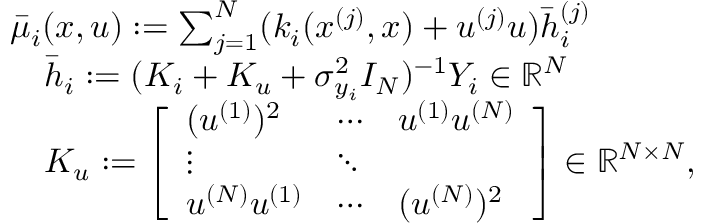<formula> <loc_0><loc_0><loc_500><loc_500>\begin{array} { r l } & { \bar { \mu } _ { i } ( x , u ) \colon = \sum _ { j = 1 } ^ { N } ( k _ { i } ( x ^ { ( j ) } , x ) + u ^ { ( j ) } u ) \bar { h } _ { i } ^ { ( j ) } } \\ & { \quad \bar { h } _ { i } \colon = ( K _ { i } + K _ { u } + \sigma _ { y _ { i } } ^ { 2 } I _ { N } ) ^ { - 1 } Y _ { i } \in { \mathbb { R } } ^ { N } } \\ & { \quad K _ { u } \colon = \left [ \begin{array} { l l l } { ( u ^ { ( 1 ) } ) ^ { 2 } } & { \cdots } & { u ^ { ( 1 ) } u ^ { ( N ) } } \\ { \vdots } & { \ddots } \\ { u ^ { ( N ) } u ^ { ( 1 ) } } & { \cdots } & { ( u ^ { ( N ) } ) ^ { 2 } } \end{array} \right ] \in { \mathbb { R } } ^ { N \times N } , } \end{array}</formula> 